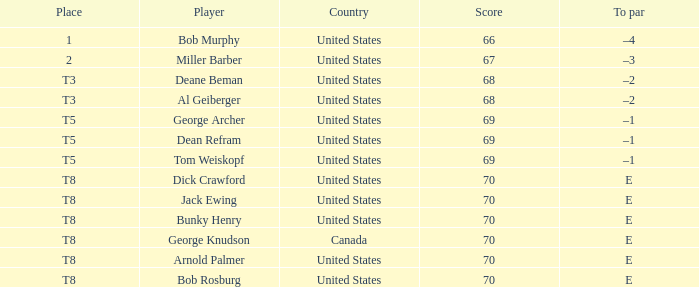When Bunky Henry of the United States scored higher than 67 and his To par was e, what was his place? T8. 